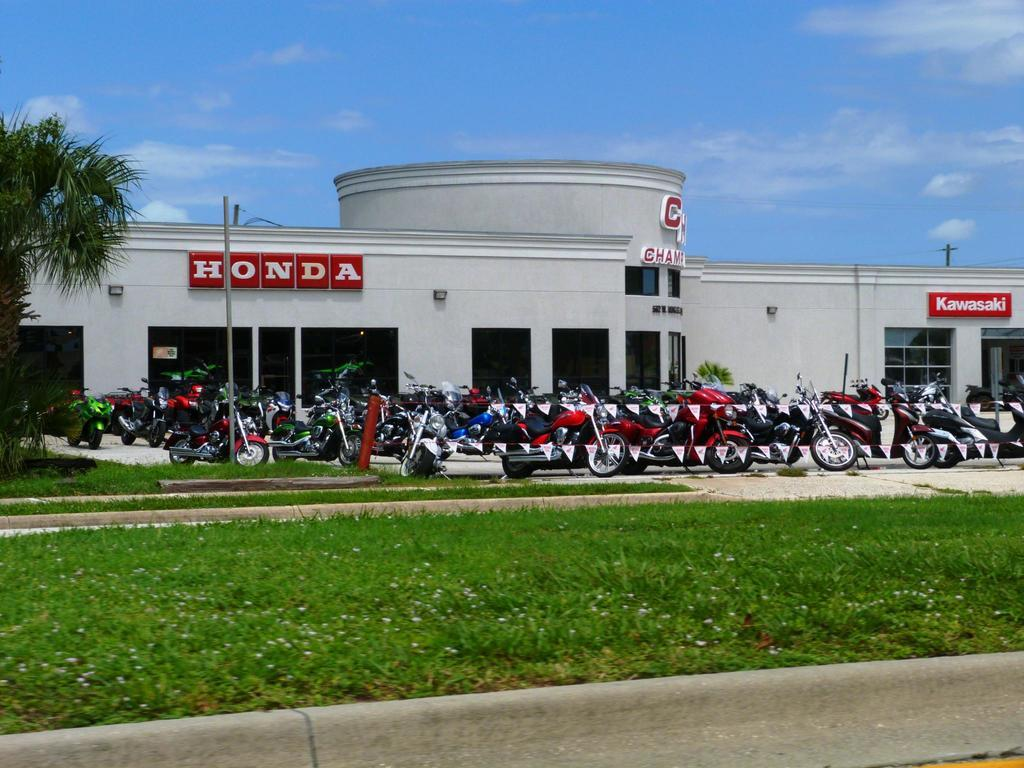What can be seen in the middle of the image? In the middle of the image, there are bikes, flags, poles, a tree, a building, and a board with text. What is present at the bottom of the image? At the bottom of the image, there are plants, grass, and flowers. What is visible at the top of the image? At the top of the image, there is sky and clouds visible. Can you hear the note being played by the flowers in the image? There are no notes or sounds associated with the flowers in the image; they are simply plants. Why are the clouds laughing in the image? The clouds in the image are not laughing, as clouds do not have the ability to laugh or express emotions. 